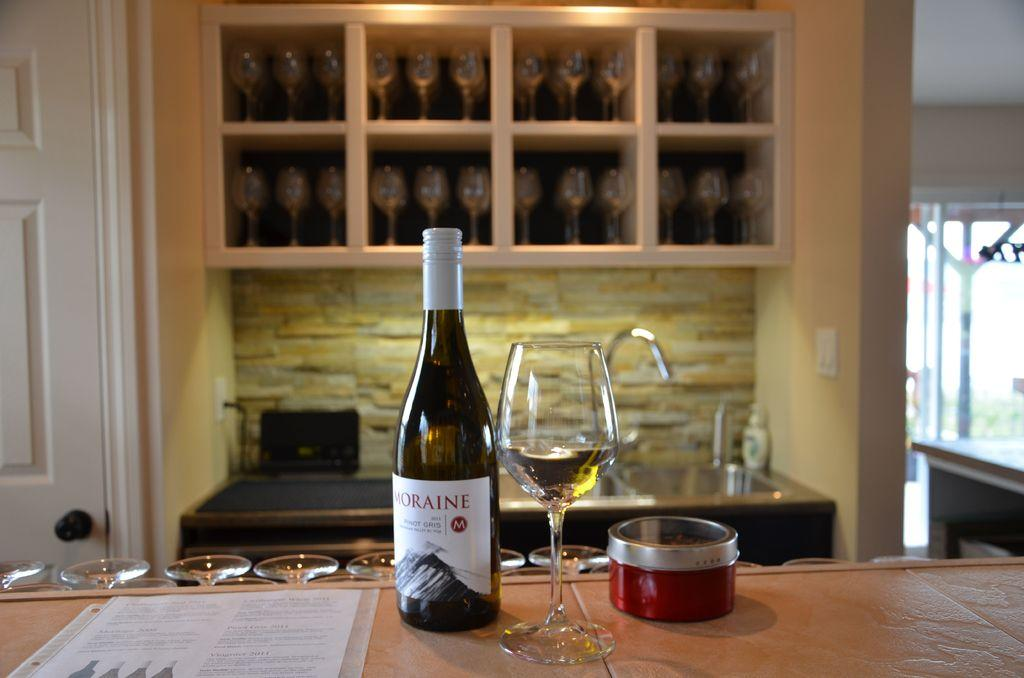What can be seen on the table in the image? There is a bottle and a glass on the table in the image. What else is related to drinking in the image? There are glasses in a rack in the image. What architectural features are present in the image? There is a door and a wall in the image. How does the stomach of the person in the image feel after drinking from the bottle? There is no person present in the image, so it is impossible to determine how their stomach feels after drinking from the bottle. 